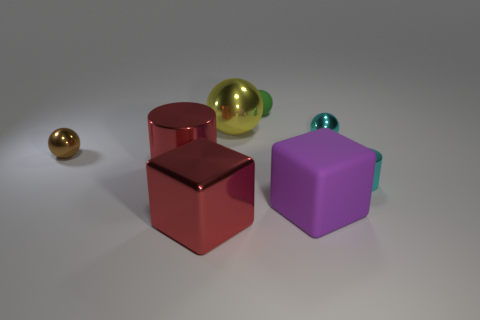What number of big yellow metallic things are in front of the matte object to the right of the small green thing?
Your answer should be compact. 0. What number of other objects are the same shape as the big yellow object?
Ensure brevity in your answer.  3. There is a big thing that is the same color as the big cylinder; what material is it?
Your answer should be compact. Metal. How many large balls are the same color as the small rubber object?
Your response must be concise. 0. The large cylinder that is made of the same material as the brown sphere is what color?
Provide a short and direct response. Red. Is there a green thing of the same size as the red metal cube?
Provide a succinct answer. No. Are there more purple matte blocks that are behind the large purple block than tiny cyan metal spheres in front of the red cylinder?
Ensure brevity in your answer.  No. Does the small thing in front of the brown ball have the same material as the cylinder left of the tiny cyan ball?
Provide a succinct answer. Yes. What is the shape of the yellow object that is the same size as the purple thing?
Make the answer very short. Sphere. Is there a large red object that has the same shape as the yellow thing?
Your response must be concise. No. 